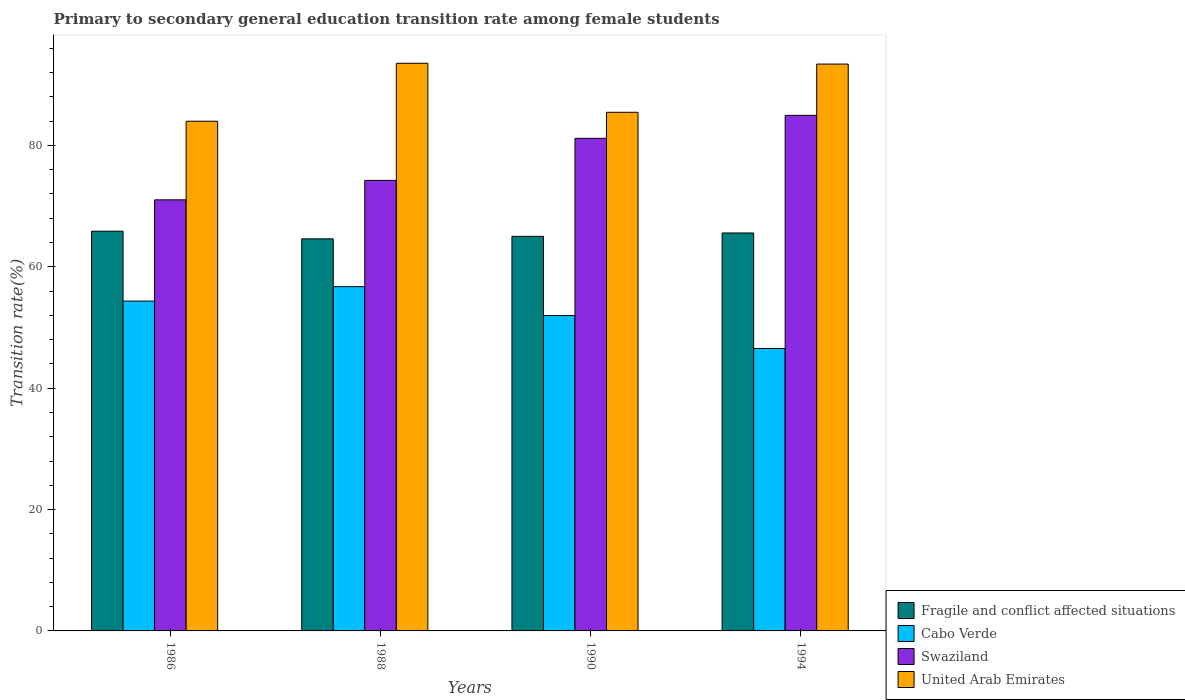How many different coloured bars are there?
Your answer should be very brief. 4. How many groups of bars are there?
Provide a short and direct response. 4. How many bars are there on the 4th tick from the left?
Give a very brief answer. 4. What is the label of the 4th group of bars from the left?
Offer a terse response. 1994. What is the transition rate in Cabo Verde in 1986?
Provide a short and direct response. 54.35. Across all years, what is the maximum transition rate in Cabo Verde?
Your answer should be very brief. 56.73. Across all years, what is the minimum transition rate in Swaziland?
Ensure brevity in your answer.  71.04. In which year was the transition rate in United Arab Emirates maximum?
Offer a terse response. 1988. In which year was the transition rate in Cabo Verde minimum?
Ensure brevity in your answer.  1994. What is the total transition rate in Swaziland in the graph?
Give a very brief answer. 311.41. What is the difference between the transition rate in United Arab Emirates in 1988 and that in 1990?
Ensure brevity in your answer.  8.08. What is the difference between the transition rate in United Arab Emirates in 1988 and the transition rate in Swaziland in 1994?
Provide a short and direct response. 8.58. What is the average transition rate in United Arab Emirates per year?
Provide a short and direct response. 89.1. In the year 1986, what is the difference between the transition rate in Swaziland and transition rate in Fragile and conflict affected situations?
Your response must be concise. 5.17. What is the ratio of the transition rate in Cabo Verde in 1986 to that in 1990?
Ensure brevity in your answer.  1.05. Is the difference between the transition rate in Swaziland in 1988 and 1994 greater than the difference between the transition rate in Fragile and conflict affected situations in 1988 and 1994?
Your answer should be compact. No. What is the difference between the highest and the second highest transition rate in United Arab Emirates?
Your answer should be very brief. 0.13. What is the difference between the highest and the lowest transition rate in United Arab Emirates?
Give a very brief answer. 9.55. Is the sum of the transition rate in Fragile and conflict affected situations in 1986 and 1994 greater than the maximum transition rate in United Arab Emirates across all years?
Your response must be concise. Yes. What does the 1st bar from the left in 1990 represents?
Provide a succinct answer. Fragile and conflict affected situations. What does the 4th bar from the right in 1994 represents?
Your answer should be compact. Fragile and conflict affected situations. How many bars are there?
Your answer should be very brief. 16. Are all the bars in the graph horizontal?
Give a very brief answer. No. Are the values on the major ticks of Y-axis written in scientific E-notation?
Your answer should be compact. No. Does the graph contain any zero values?
Provide a short and direct response. No. Does the graph contain grids?
Provide a short and direct response. No. Where does the legend appear in the graph?
Your response must be concise. Bottom right. How many legend labels are there?
Give a very brief answer. 4. What is the title of the graph?
Ensure brevity in your answer.  Primary to secondary general education transition rate among female students. Does "Lower middle income" appear as one of the legend labels in the graph?
Give a very brief answer. No. What is the label or title of the Y-axis?
Your answer should be compact. Transition rate(%). What is the Transition rate(%) of Fragile and conflict affected situations in 1986?
Make the answer very short. 65.87. What is the Transition rate(%) of Cabo Verde in 1986?
Offer a terse response. 54.35. What is the Transition rate(%) in Swaziland in 1986?
Provide a succinct answer. 71.04. What is the Transition rate(%) in United Arab Emirates in 1986?
Your response must be concise. 83.99. What is the Transition rate(%) in Fragile and conflict affected situations in 1988?
Keep it short and to the point. 64.61. What is the Transition rate(%) of Cabo Verde in 1988?
Offer a very short reply. 56.73. What is the Transition rate(%) in Swaziland in 1988?
Provide a succinct answer. 74.24. What is the Transition rate(%) of United Arab Emirates in 1988?
Keep it short and to the point. 93.54. What is the Transition rate(%) in Fragile and conflict affected situations in 1990?
Keep it short and to the point. 65.02. What is the Transition rate(%) of Cabo Verde in 1990?
Keep it short and to the point. 51.97. What is the Transition rate(%) in Swaziland in 1990?
Offer a very short reply. 81.17. What is the Transition rate(%) in United Arab Emirates in 1990?
Your response must be concise. 85.46. What is the Transition rate(%) in Fragile and conflict affected situations in 1994?
Offer a very short reply. 65.58. What is the Transition rate(%) in Cabo Verde in 1994?
Your response must be concise. 46.54. What is the Transition rate(%) of Swaziland in 1994?
Your answer should be compact. 84.96. What is the Transition rate(%) in United Arab Emirates in 1994?
Your answer should be very brief. 93.41. Across all years, what is the maximum Transition rate(%) in Fragile and conflict affected situations?
Your response must be concise. 65.87. Across all years, what is the maximum Transition rate(%) of Cabo Verde?
Ensure brevity in your answer.  56.73. Across all years, what is the maximum Transition rate(%) of Swaziland?
Provide a short and direct response. 84.96. Across all years, what is the maximum Transition rate(%) of United Arab Emirates?
Ensure brevity in your answer.  93.54. Across all years, what is the minimum Transition rate(%) of Fragile and conflict affected situations?
Ensure brevity in your answer.  64.61. Across all years, what is the minimum Transition rate(%) of Cabo Verde?
Keep it short and to the point. 46.54. Across all years, what is the minimum Transition rate(%) of Swaziland?
Make the answer very short. 71.04. Across all years, what is the minimum Transition rate(%) of United Arab Emirates?
Provide a short and direct response. 83.99. What is the total Transition rate(%) in Fragile and conflict affected situations in the graph?
Your answer should be very brief. 261.08. What is the total Transition rate(%) in Cabo Verde in the graph?
Make the answer very short. 209.59. What is the total Transition rate(%) in Swaziland in the graph?
Your answer should be compact. 311.41. What is the total Transition rate(%) of United Arab Emirates in the graph?
Your answer should be compact. 356.41. What is the difference between the Transition rate(%) of Fragile and conflict affected situations in 1986 and that in 1988?
Offer a terse response. 1.26. What is the difference between the Transition rate(%) in Cabo Verde in 1986 and that in 1988?
Offer a terse response. -2.38. What is the difference between the Transition rate(%) of Swaziland in 1986 and that in 1988?
Offer a very short reply. -3.2. What is the difference between the Transition rate(%) in United Arab Emirates in 1986 and that in 1988?
Make the answer very short. -9.55. What is the difference between the Transition rate(%) in Fragile and conflict affected situations in 1986 and that in 1990?
Offer a very short reply. 0.85. What is the difference between the Transition rate(%) of Cabo Verde in 1986 and that in 1990?
Make the answer very short. 2.38. What is the difference between the Transition rate(%) in Swaziland in 1986 and that in 1990?
Give a very brief answer. -10.14. What is the difference between the Transition rate(%) of United Arab Emirates in 1986 and that in 1990?
Keep it short and to the point. -1.47. What is the difference between the Transition rate(%) in Fragile and conflict affected situations in 1986 and that in 1994?
Give a very brief answer. 0.29. What is the difference between the Transition rate(%) of Cabo Verde in 1986 and that in 1994?
Your answer should be compact. 7.81. What is the difference between the Transition rate(%) of Swaziland in 1986 and that in 1994?
Make the answer very short. -13.92. What is the difference between the Transition rate(%) in United Arab Emirates in 1986 and that in 1994?
Your answer should be very brief. -9.42. What is the difference between the Transition rate(%) in Fragile and conflict affected situations in 1988 and that in 1990?
Provide a succinct answer. -0.41. What is the difference between the Transition rate(%) of Cabo Verde in 1988 and that in 1990?
Your response must be concise. 4.76. What is the difference between the Transition rate(%) in Swaziland in 1988 and that in 1990?
Offer a very short reply. -6.93. What is the difference between the Transition rate(%) of United Arab Emirates in 1988 and that in 1990?
Provide a short and direct response. 8.08. What is the difference between the Transition rate(%) of Fragile and conflict affected situations in 1988 and that in 1994?
Ensure brevity in your answer.  -0.97. What is the difference between the Transition rate(%) of Cabo Verde in 1988 and that in 1994?
Offer a terse response. 10.19. What is the difference between the Transition rate(%) of Swaziland in 1988 and that in 1994?
Provide a short and direct response. -10.72. What is the difference between the Transition rate(%) in United Arab Emirates in 1988 and that in 1994?
Make the answer very short. 0.13. What is the difference between the Transition rate(%) of Fragile and conflict affected situations in 1990 and that in 1994?
Ensure brevity in your answer.  -0.56. What is the difference between the Transition rate(%) of Cabo Verde in 1990 and that in 1994?
Keep it short and to the point. 5.43. What is the difference between the Transition rate(%) of Swaziland in 1990 and that in 1994?
Give a very brief answer. -3.79. What is the difference between the Transition rate(%) in United Arab Emirates in 1990 and that in 1994?
Ensure brevity in your answer.  -7.95. What is the difference between the Transition rate(%) of Fragile and conflict affected situations in 1986 and the Transition rate(%) of Cabo Verde in 1988?
Your answer should be very brief. 9.14. What is the difference between the Transition rate(%) in Fragile and conflict affected situations in 1986 and the Transition rate(%) in Swaziland in 1988?
Keep it short and to the point. -8.37. What is the difference between the Transition rate(%) in Fragile and conflict affected situations in 1986 and the Transition rate(%) in United Arab Emirates in 1988?
Offer a very short reply. -27.67. What is the difference between the Transition rate(%) in Cabo Verde in 1986 and the Transition rate(%) in Swaziland in 1988?
Your answer should be compact. -19.89. What is the difference between the Transition rate(%) in Cabo Verde in 1986 and the Transition rate(%) in United Arab Emirates in 1988?
Keep it short and to the point. -39.19. What is the difference between the Transition rate(%) in Swaziland in 1986 and the Transition rate(%) in United Arab Emirates in 1988?
Your response must be concise. -22.51. What is the difference between the Transition rate(%) in Fragile and conflict affected situations in 1986 and the Transition rate(%) in Cabo Verde in 1990?
Provide a succinct answer. 13.9. What is the difference between the Transition rate(%) of Fragile and conflict affected situations in 1986 and the Transition rate(%) of Swaziland in 1990?
Provide a succinct answer. -15.3. What is the difference between the Transition rate(%) of Fragile and conflict affected situations in 1986 and the Transition rate(%) of United Arab Emirates in 1990?
Ensure brevity in your answer.  -19.59. What is the difference between the Transition rate(%) of Cabo Verde in 1986 and the Transition rate(%) of Swaziland in 1990?
Ensure brevity in your answer.  -26.82. What is the difference between the Transition rate(%) of Cabo Verde in 1986 and the Transition rate(%) of United Arab Emirates in 1990?
Offer a terse response. -31.11. What is the difference between the Transition rate(%) in Swaziland in 1986 and the Transition rate(%) in United Arab Emirates in 1990?
Your answer should be compact. -14.43. What is the difference between the Transition rate(%) of Fragile and conflict affected situations in 1986 and the Transition rate(%) of Cabo Verde in 1994?
Ensure brevity in your answer.  19.33. What is the difference between the Transition rate(%) of Fragile and conflict affected situations in 1986 and the Transition rate(%) of Swaziland in 1994?
Provide a succinct answer. -19.09. What is the difference between the Transition rate(%) in Fragile and conflict affected situations in 1986 and the Transition rate(%) in United Arab Emirates in 1994?
Your response must be concise. -27.54. What is the difference between the Transition rate(%) in Cabo Verde in 1986 and the Transition rate(%) in Swaziland in 1994?
Provide a succinct answer. -30.61. What is the difference between the Transition rate(%) in Cabo Verde in 1986 and the Transition rate(%) in United Arab Emirates in 1994?
Provide a succinct answer. -39.06. What is the difference between the Transition rate(%) of Swaziland in 1986 and the Transition rate(%) of United Arab Emirates in 1994?
Your answer should be very brief. -22.37. What is the difference between the Transition rate(%) of Fragile and conflict affected situations in 1988 and the Transition rate(%) of Cabo Verde in 1990?
Make the answer very short. 12.64. What is the difference between the Transition rate(%) in Fragile and conflict affected situations in 1988 and the Transition rate(%) in Swaziland in 1990?
Make the answer very short. -16.56. What is the difference between the Transition rate(%) of Fragile and conflict affected situations in 1988 and the Transition rate(%) of United Arab Emirates in 1990?
Your response must be concise. -20.85. What is the difference between the Transition rate(%) in Cabo Verde in 1988 and the Transition rate(%) in Swaziland in 1990?
Make the answer very short. -24.44. What is the difference between the Transition rate(%) in Cabo Verde in 1988 and the Transition rate(%) in United Arab Emirates in 1990?
Keep it short and to the point. -28.73. What is the difference between the Transition rate(%) in Swaziland in 1988 and the Transition rate(%) in United Arab Emirates in 1990?
Keep it short and to the point. -11.22. What is the difference between the Transition rate(%) in Fragile and conflict affected situations in 1988 and the Transition rate(%) in Cabo Verde in 1994?
Your answer should be very brief. 18.07. What is the difference between the Transition rate(%) of Fragile and conflict affected situations in 1988 and the Transition rate(%) of Swaziland in 1994?
Provide a short and direct response. -20.35. What is the difference between the Transition rate(%) in Fragile and conflict affected situations in 1988 and the Transition rate(%) in United Arab Emirates in 1994?
Keep it short and to the point. -28.8. What is the difference between the Transition rate(%) of Cabo Verde in 1988 and the Transition rate(%) of Swaziland in 1994?
Your response must be concise. -28.23. What is the difference between the Transition rate(%) of Cabo Verde in 1988 and the Transition rate(%) of United Arab Emirates in 1994?
Keep it short and to the point. -36.68. What is the difference between the Transition rate(%) of Swaziland in 1988 and the Transition rate(%) of United Arab Emirates in 1994?
Your answer should be compact. -19.17. What is the difference between the Transition rate(%) in Fragile and conflict affected situations in 1990 and the Transition rate(%) in Cabo Verde in 1994?
Your answer should be compact. 18.48. What is the difference between the Transition rate(%) of Fragile and conflict affected situations in 1990 and the Transition rate(%) of Swaziland in 1994?
Provide a succinct answer. -19.94. What is the difference between the Transition rate(%) of Fragile and conflict affected situations in 1990 and the Transition rate(%) of United Arab Emirates in 1994?
Your answer should be very brief. -28.39. What is the difference between the Transition rate(%) of Cabo Verde in 1990 and the Transition rate(%) of Swaziland in 1994?
Your answer should be compact. -32.99. What is the difference between the Transition rate(%) of Cabo Verde in 1990 and the Transition rate(%) of United Arab Emirates in 1994?
Give a very brief answer. -41.44. What is the difference between the Transition rate(%) of Swaziland in 1990 and the Transition rate(%) of United Arab Emirates in 1994?
Give a very brief answer. -12.24. What is the average Transition rate(%) in Fragile and conflict affected situations per year?
Keep it short and to the point. 65.27. What is the average Transition rate(%) in Cabo Verde per year?
Make the answer very short. 52.4. What is the average Transition rate(%) of Swaziland per year?
Make the answer very short. 77.85. What is the average Transition rate(%) of United Arab Emirates per year?
Offer a very short reply. 89.1. In the year 1986, what is the difference between the Transition rate(%) of Fragile and conflict affected situations and Transition rate(%) of Cabo Verde?
Ensure brevity in your answer.  11.52. In the year 1986, what is the difference between the Transition rate(%) of Fragile and conflict affected situations and Transition rate(%) of Swaziland?
Your answer should be compact. -5.17. In the year 1986, what is the difference between the Transition rate(%) in Fragile and conflict affected situations and Transition rate(%) in United Arab Emirates?
Offer a very short reply. -18.12. In the year 1986, what is the difference between the Transition rate(%) in Cabo Verde and Transition rate(%) in Swaziland?
Your response must be concise. -16.69. In the year 1986, what is the difference between the Transition rate(%) in Cabo Verde and Transition rate(%) in United Arab Emirates?
Make the answer very short. -29.64. In the year 1986, what is the difference between the Transition rate(%) in Swaziland and Transition rate(%) in United Arab Emirates?
Make the answer very short. -12.95. In the year 1988, what is the difference between the Transition rate(%) of Fragile and conflict affected situations and Transition rate(%) of Cabo Verde?
Keep it short and to the point. 7.88. In the year 1988, what is the difference between the Transition rate(%) of Fragile and conflict affected situations and Transition rate(%) of Swaziland?
Your answer should be very brief. -9.63. In the year 1988, what is the difference between the Transition rate(%) of Fragile and conflict affected situations and Transition rate(%) of United Arab Emirates?
Your response must be concise. -28.93. In the year 1988, what is the difference between the Transition rate(%) in Cabo Verde and Transition rate(%) in Swaziland?
Provide a short and direct response. -17.51. In the year 1988, what is the difference between the Transition rate(%) in Cabo Verde and Transition rate(%) in United Arab Emirates?
Give a very brief answer. -36.81. In the year 1988, what is the difference between the Transition rate(%) of Swaziland and Transition rate(%) of United Arab Emirates?
Ensure brevity in your answer.  -19.3. In the year 1990, what is the difference between the Transition rate(%) of Fragile and conflict affected situations and Transition rate(%) of Cabo Verde?
Ensure brevity in your answer.  13.05. In the year 1990, what is the difference between the Transition rate(%) in Fragile and conflict affected situations and Transition rate(%) in Swaziland?
Give a very brief answer. -16.15. In the year 1990, what is the difference between the Transition rate(%) in Fragile and conflict affected situations and Transition rate(%) in United Arab Emirates?
Make the answer very short. -20.44. In the year 1990, what is the difference between the Transition rate(%) in Cabo Verde and Transition rate(%) in Swaziland?
Your response must be concise. -29.21. In the year 1990, what is the difference between the Transition rate(%) in Cabo Verde and Transition rate(%) in United Arab Emirates?
Your response must be concise. -33.5. In the year 1990, what is the difference between the Transition rate(%) of Swaziland and Transition rate(%) of United Arab Emirates?
Your response must be concise. -4.29. In the year 1994, what is the difference between the Transition rate(%) of Fragile and conflict affected situations and Transition rate(%) of Cabo Verde?
Give a very brief answer. 19.03. In the year 1994, what is the difference between the Transition rate(%) in Fragile and conflict affected situations and Transition rate(%) in Swaziland?
Your response must be concise. -19.38. In the year 1994, what is the difference between the Transition rate(%) of Fragile and conflict affected situations and Transition rate(%) of United Arab Emirates?
Your answer should be compact. -27.83. In the year 1994, what is the difference between the Transition rate(%) of Cabo Verde and Transition rate(%) of Swaziland?
Ensure brevity in your answer.  -38.42. In the year 1994, what is the difference between the Transition rate(%) of Cabo Verde and Transition rate(%) of United Arab Emirates?
Provide a succinct answer. -46.87. In the year 1994, what is the difference between the Transition rate(%) in Swaziland and Transition rate(%) in United Arab Emirates?
Offer a very short reply. -8.45. What is the ratio of the Transition rate(%) in Fragile and conflict affected situations in 1986 to that in 1988?
Make the answer very short. 1.02. What is the ratio of the Transition rate(%) in Cabo Verde in 1986 to that in 1988?
Give a very brief answer. 0.96. What is the ratio of the Transition rate(%) of Swaziland in 1986 to that in 1988?
Your answer should be compact. 0.96. What is the ratio of the Transition rate(%) in United Arab Emirates in 1986 to that in 1988?
Offer a terse response. 0.9. What is the ratio of the Transition rate(%) of Fragile and conflict affected situations in 1986 to that in 1990?
Ensure brevity in your answer.  1.01. What is the ratio of the Transition rate(%) in Cabo Verde in 1986 to that in 1990?
Your answer should be very brief. 1.05. What is the ratio of the Transition rate(%) in Swaziland in 1986 to that in 1990?
Ensure brevity in your answer.  0.88. What is the ratio of the Transition rate(%) of United Arab Emirates in 1986 to that in 1990?
Provide a succinct answer. 0.98. What is the ratio of the Transition rate(%) of Cabo Verde in 1986 to that in 1994?
Offer a very short reply. 1.17. What is the ratio of the Transition rate(%) of Swaziland in 1986 to that in 1994?
Keep it short and to the point. 0.84. What is the ratio of the Transition rate(%) in United Arab Emirates in 1986 to that in 1994?
Your answer should be very brief. 0.9. What is the ratio of the Transition rate(%) in Cabo Verde in 1988 to that in 1990?
Your answer should be compact. 1.09. What is the ratio of the Transition rate(%) in Swaziland in 1988 to that in 1990?
Make the answer very short. 0.91. What is the ratio of the Transition rate(%) of United Arab Emirates in 1988 to that in 1990?
Your response must be concise. 1.09. What is the ratio of the Transition rate(%) of Fragile and conflict affected situations in 1988 to that in 1994?
Your response must be concise. 0.99. What is the ratio of the Transition rate(%) in Cabo Verde in 1988 to that in 1994?
Your answer should be compact. 1.22. What is the ratio of the Transition rate(%) in Swaziland in 1988 to that in 1994?
Make the answer very short. 0.87. What is the ratio of the Transition rate(%) of United Arab Emirates in 1988 to that in 1994?
Give a very brief answer. 1. What is the ratio of the Transition rate(%) of Fragile and conflict affected situations in 1990 to that in 1994?
Offer a terse response. 0.99. What is the ratio of the Transition rate(%) in Cabo Verde in 1990 to that in 1994?
Make the answer very short. 1.12. What is the ratio of the Transition rate(%) in Swaziland in 1990 to that in 1994?
Ensure brevity in your answer.  0.96. What is the ratio of the Transition rate(%) in United Arab Emirates in 1990 to that in 1994?
Your answer should be compact. 0.91. What is the difference between the highest and the second highest Transition rate(%) of Fragile and conflict affected situations?
Ensure brevity in your answer.  0.29. What is the difference between the highest and the second highest Transition rate(%) of Cabo Verde?
Your response must be concise. 2.38. What is the difference between the highest and the second highest Transition rate(%) in Swaziland?
Provide a succinct answer. 3.79. What is the difference between the highest and the second highest Transition rate(%) of United Arab Emirates?
Keep it short and to the point. 0.13. What is the difference between the highest and the lowest Transition rate(%) of Fragile and conflict affected situations?
Give a very brief answer. 1.26. What is the difference between the highest and the lowest Transition rate(%) of Cabo Verde?
Your answer should be very brief. 10.19. What is the difference between the highest and the lowest Transition rate(%) of Swaziland?
Give a very brief answer. 13.92. What is the difference between the highest and the lowest Transition rate(%) of United Arab Emirates?
Make the answer very short. 9.55. 